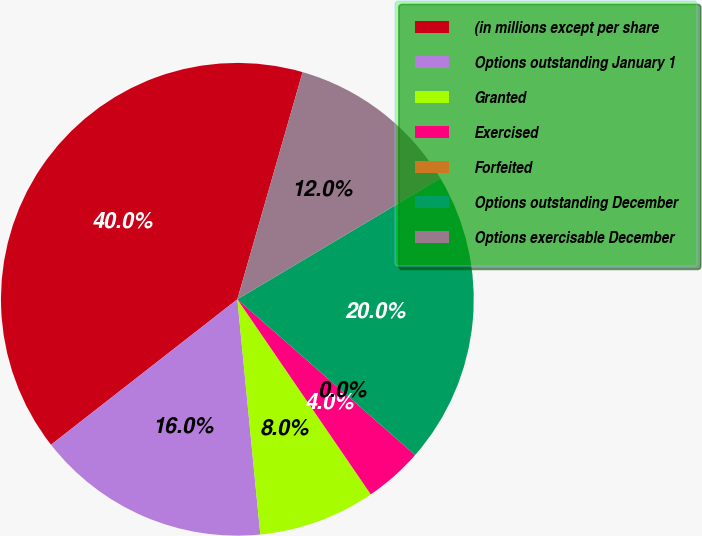<chart> <loc_0><loc_0><loc_500><loc_500><pie_chart><fcel>(in millions except per share<fcel>Options outstanding January 1<fcel>Granted<fcel>Exercised<fcel>Forfeited<fcel>Options outstanding December<fcel>Options exercisable December<nl><fcel>40.0%<fcel>16.0%<fcel>8.0%<fcel>4.0%<fcel>0.0%<fcel>20.0%<fcel>12.0%<nl></chart> 